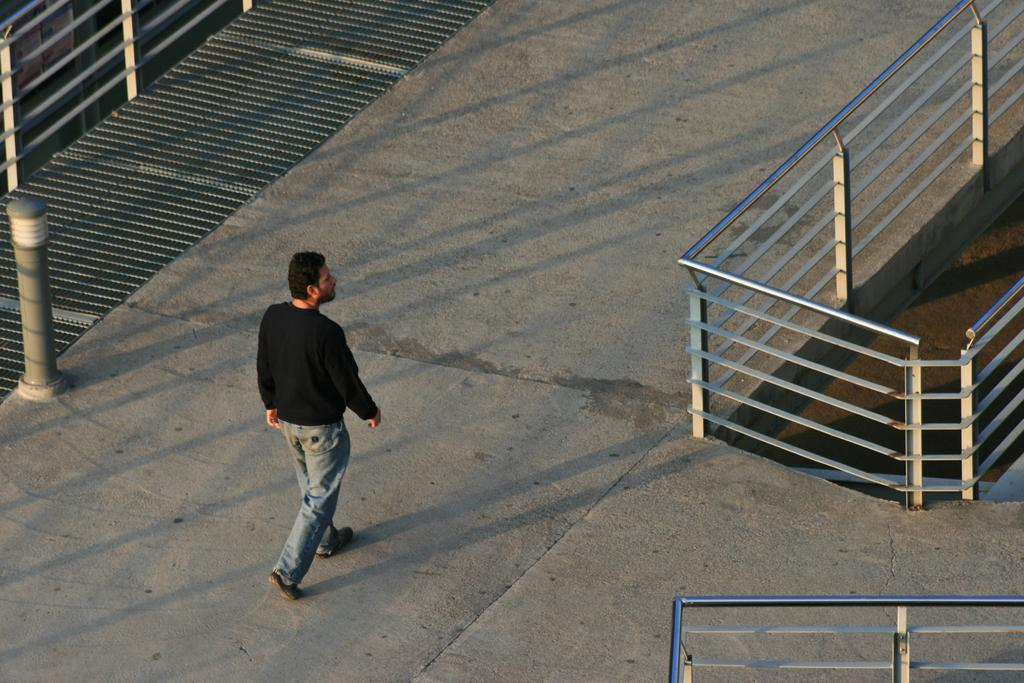What is the person in the image doing? The person is walking in the image. What is the color of the surface the person is walking on? The person is walking on an ash-colored surface. What is the person wearing? The person is wearing a black and blue dress. What structures are visible in the image? There is a pole and a railing visible in the image. What month is it in the image? The month cannot be determined from the image, as there is no information about the time of year or any seasonal indicators present. 